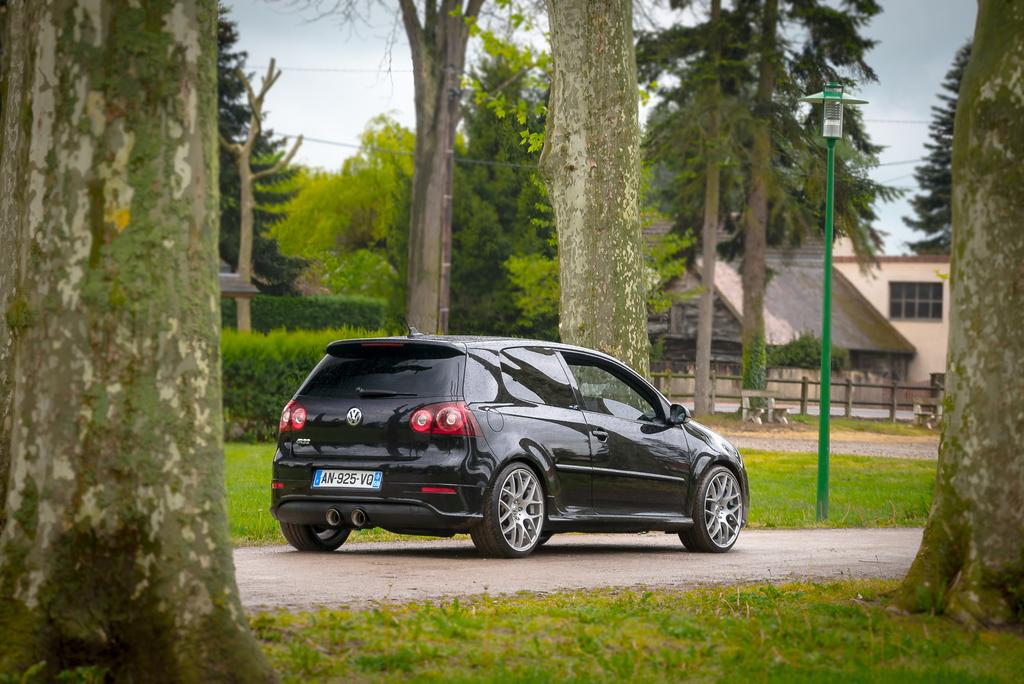What type of vegetation can be seen in the image? There is grass in the image. What is located on the road in the image? There is a car on the road in the image. What can be seen in the background of the image? There are trees, a house, and the sky visible in the background of the image. What type of glove is being exchanged between the sun and the trees in the image? There is no glove present in the image, nor is there any interaction between the sun and the trees. 